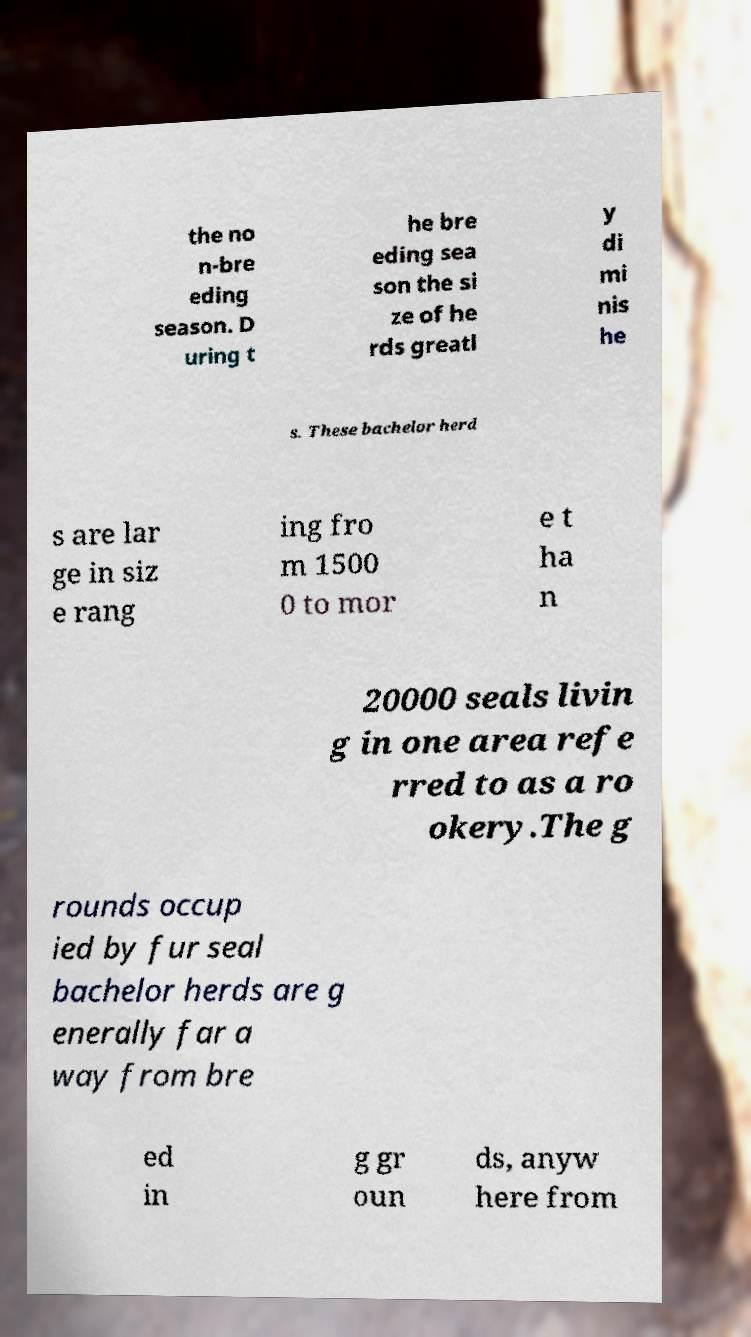Can you accurately transcribe the text from the provided image for me? the no n-bre eding season. D uring t he bre eding sea son the si ze of he rds greatl y di mi nis he s. These bachelor herd s are lar ge in siz e rang ing fro m 1500 0 to mor e t ha n 20000 seals livin g in one area refe rred to as a ro okery.The g rounds occup ied by fur seal bachelor herds are g enerally far a way from bre ed in g gr oun ds, anyw here from 